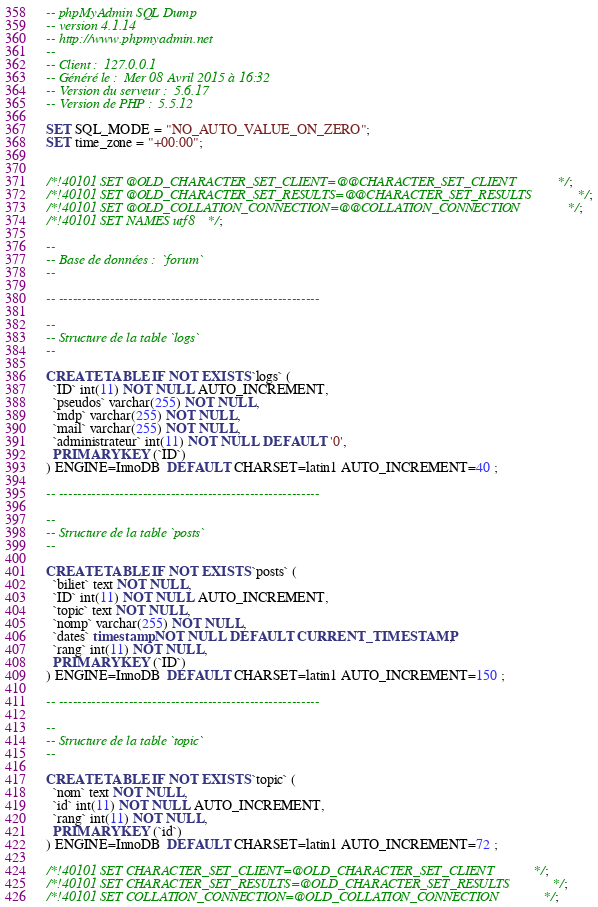<code> <loc_0><loc_0><loc_500><loc_500><_SQL_>-- phpMyAdmin SQL Dump
-- version 4.1.14
-- http://www.phpmyadmin.net
--
-- Client :  127.0.0.1
-- Généré le :  Mer 08 Avril 2015 à 16:32
-- Version du serveur :  5.6.17
-- Version de PHP :  5.5.12

SET SQL_MODE = "NO_AUTO_VALUE_ON_ZERO";
SET time_zone = "+00:00";


/*!40101 SET @OLD_CHARACTER_SET_CLIENT=@@CHARACTER_SET_CLIENT */;
/*!40101 SET @OLD_CHARACTER_SET_RESULTS=@@CHARACTER_SET_RESULTS */;
/*!40101 SET @OLD_COLLATION_CONNECTION=@@COLLATION_CONNECTION */;
/*!40101 SET NAMES utf8 */;

--
-- Base de données :  `forum`
--

-- --------------------------------------------------------

--
-- Structure de la table `logs`
--

CREATE TABLE IF NOT EXISTS `logs` (
  `ID` int(11) NOT NULL AUTO_INCREMENT,
  `pseudos` varchar(255) NOT NULL,
  `mdp` varchar(255) NOT NULL,
  `mail` varchar(255) NOT NULL,
  `administrateur` int(11) NOT NULL DEFAULT '0',
  PRIMARY KEY (`ID`)
) ENGINE=InnoDB  DEFAULT CHARSET=latin1 AUTO_INCREMENT=40 ;

-- --------------------------------------------------------

--
-- Structure de la table `posts`
--

CREATE TABLE IF NOT EXISTS `posts` (
  `biliet` text NOT NULL,
  `ID` int(11) NOT NULL AUTO_INCREMENT,
  `topic` text NOT NULL,
  `nomp` varchar(255) NOT NULL,
  `dates` timestamp NOT NULL DEFAULT CURRENT_TIMESTAMP,
  `rang` int(11) NOT NULL,
  PRIMARY KEY (`ID`)
) ENGINE=InnoDB  DEFAULT CHARSET=latin1 AUTO_INCREMENT=150 ;

-- --------------------------------------------------------

--
-- Structure de la table `topic`
--

CREATE TABLE IF NOT EXISTS `topic` (
  `nom` text NOT NULL,
  `id` int(11) NOT NULL AUTO_INCREMENT,
  `rang` int(11) NOT NULL,
  PRIMARY KEY (`id`)
) ENGINE=InnoDB  DEFAULT CHARSET=latin1 AUTO_INCREMENT=72 ;

/*!40101 SET CHARACTER_SET_CLIENT=@OLD_CHARACTER_SET_CLIENT */;
/*!40101 SET CHARACTER_SET_RESULTS=@OLD_CHARACTER_SET_RESULTS */;
/*!40101 SET COLLATION_CONNECTION=@OLD_COLLATION_CONNECTION */;
</code> 